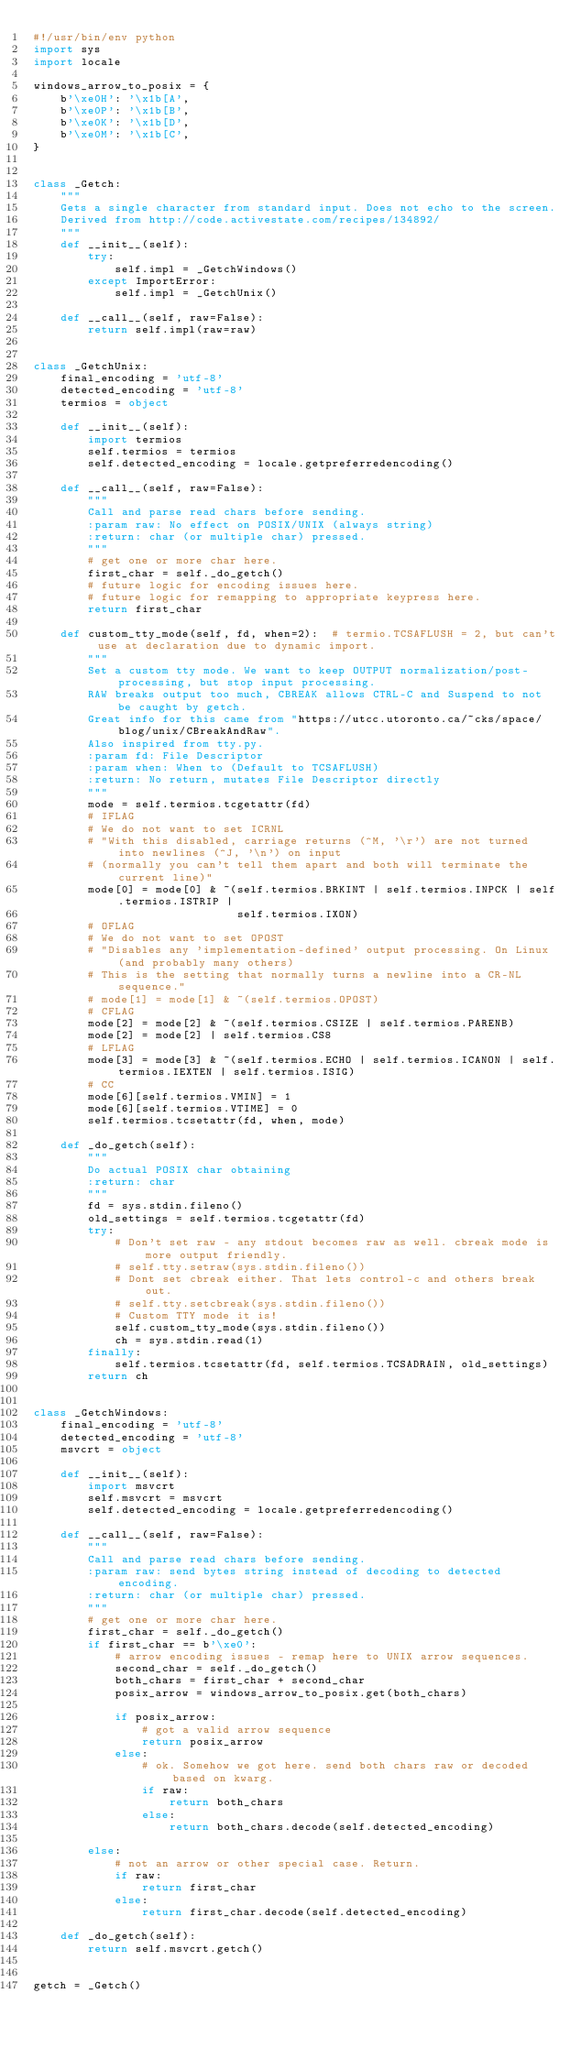Convert code to text. <code><loc_0><loc_0><loc_500><loc_500><_Python_>#!/usr/bin/env python
import sys
import locale

windows_arrow_to_posix = {
    b'\xe0H': '\x1b[A',
    b'\xe0P': '\x1b[B',
    b'\xe0K': '\x1b[D',
    b'\xe0M': '\x1b[C',
}


class _Getch:
    """
    Gets a single character from standard input. Does not echo to the screen.
    Derived from http://code.activestate.com/recipes/134892/
    """
    def __init__(self):
        try:
            self.impl = _GetchWindows()
        except ImportError:
            self.impl = _GetchUnix()

    def __call__(self, raw=False):
        return self.impl(raw=raw)


class _GetchUnix:
    final_encoding = 'utf-8'
    detected_encoding = 'utf-8'
    termios = object

    def __init__(self):
        import termios
        self.termios = termios
        self.detected_encoding = locale.getpreferredencoding()

    def __call__(self, raw=False):
        """
        Call and parse read chars before sending.
        :param raw: No effect on POSIX/UNIX (always string)
        :return: char (or multiple char) pressed.
        """
        # get one or more char here.
        first_char = self._do_getch()
        # future logic for encoding issues here.
        # future logic for remapping to appropriate keypress here.
        return first_char

    def custom_tty_mode(self, fd, when=2):  # termio.TCSAFLUSH = 2, but can't use at declaration due to dynamic import.
        """
        Set a custom tty mode. We want to keep OUTPUT normalization/post-processing, but stop input processing.
        RAW breaks output too much, CBREAK allows CTRL-C and Suspend to not be caught by getch.
        Great info for this came from "https://utcc.utoronto.ca/~cks/space/blog/unix/CBreakAndRaw".
        Also inspired from tty.py.
        :param fd: File Descriptor
        :param when: When to (Default to TCSAFLUSH)
        :return: No return, mutates File Descriptor directly
        """
        mode = self.termios.tcgetattr(fd)
        # IFLAG
        # We do not want to set ICRNL
        # "With this disabled, carriage returns (^M, '\r') are not turned into newlines (^J, '\n') on input
        # (normally you can't tell them apart and both will terminate the current line)"
        mode[0] = mode[0] & ~(self.termios.BRKINT | self.termios.INPCK | self.termios.ISTRIP |
                              self.termios.IXON)
        # OFLAG
        # We do not want to set OPOST
        # "Disables any 'implementation-defined' output processing. On Linux (and probably many others)
        # This is the setting that normally turns a newline into a CR-NL sequence."
        # mode[1] = mode[1] & ~(self.termios.OPOST)
        # CFLAG
        mode[2] = mode[2] & ~(self.termios.CSIZE | self.termios.PARENB)
        mode[2] = mode[2] | self.termios.CS8
        # LFLAG
        mode[3] = mode[3] & ~(self.termios.ECHO | self.termios.ICANON | self.termios.IEXTEN | self.termios.ISIG)
        # CC
        mode[6][self.termios.VMIN] = 1
        mode[6][self.termios.VTIME] = 0
        self.termios.tcsetattr(fd, when, mode)

    def _do_getch(self):
        """
        Do actual POSIX char obtaining
        :return: char
        """
        fd = sys.stdin.fileno()
        old_settings = self.termios.tcgetattr(fd)
        try:
            # Don't set raw - any stdout becomes raw as well. cbreak mode is more output friendly.
            # self.tty.setraw(sys.stdin.fileno())
            # Dont set cbreak either. That lets control-c and others break out.
            # self.tty.setcbreak(sys.stdin.fileno())
            # Custom TTY mode it is!
            self.custom_tty_mode(sys.stdin.fileno())
            ch = sys.stdin.read(1)
        finally:
            self.termios.tcsetattr(fd, self.termios.TCSADRAIN, old_settings)
        return ch


class _GetchWindows:
    final_encoding = 'utf-8'
    detected_encoding = 'utf-8'
    msvcrt = object

    def __init__(self):
        import msvcrt
        self.msvcrt = msvcrt
        self.detected_encoding = locale.getpreferredencoding()

    def __call__(self, raw=False):
        """
        Call and parse read chars before sending.
        :param raw: send bytes string instead of decoding to detected encoding.
        :return: char (or multiple char) pressed.
        """
        # get one or more char here.
        first_char = self._do_getch()
        if first_char == b'\xe0':
            # arrow encoding issues - remap here to UNIX arrow sequences.
            second_char = self._do_getch()
            both_chars = first_char + second_char
            posix_arrow = windows_arrow_to_posix.get(both_chars)

            if posix_arrow:
                # got a valid arrow sequence
                return posix_arrow
            else:
                # ok. Somehow we got here. send both chars raw or decoded based on kwarg.
                if raw:
                    return both_chars
                else:
                    return both_chars.decode(self.detected_encoding)

        else:
            # not an arrow or other special case. Return.
            if raw:
                return first_char
            else:
                return first_char.decode(self.detected_encoding)

    def _do_getch(self):
        return self.msvcrt.getch()


getch = _Getch()
</code> 